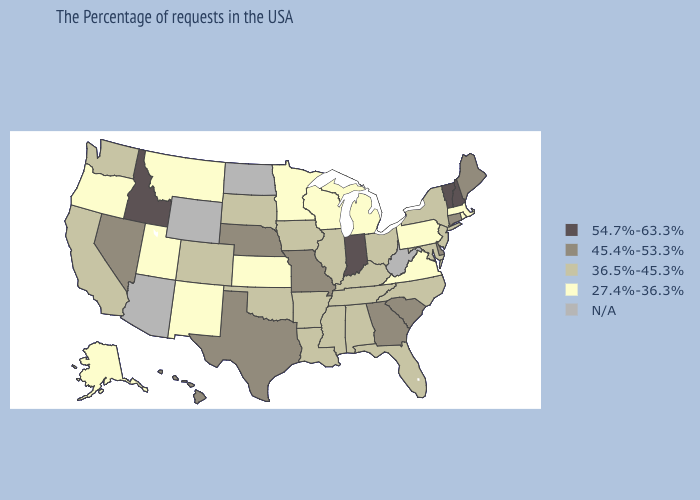Does Mississippi have the lowest value in the South?
Concise answer only. No. Name the states that have a value in the range 54.7%-63.3%?
Keep it brief. New Hampshire, Vermont, Indiana, Idaho. What is the value of Wisconsin?
Concise answer only. 27.4%-36.3%. What is the value of Virginia?
Keep it brief. 27.4%-36.3%. What is the lowest value in the Northeast?
Quick response, please. 27.4%-36.3%. What is the highest value in states that border South Carolina?
Give a very brief answer. 45.4%-53.3%. Does Indiana have the highest value in the MidWest?
Quick response, please. Yes. Does Idaho have the highest value in the West?
Give a very brief answer. Yes. Is the legend a continuous bar?
Quick response, please. No. Name the states that have a value in the range 54.7%-63.3%?
Be succinct. New Hampshire, Vermont, Indiana, Idaho. Name the states that have a value in the range N/A?
Be succinct. West Virginia, North Dakota, Wyoming, Arizona. What is the lowest value in states that border Connecticut?
Concise answer only. 27.4%-36.3%. Among the states that border Kentucky , does Virginia have the lowest value?
Answer briefly. Yes. 